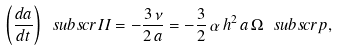<formula> <loc_0><loc_0><loc_500><loc_500>\left ( \frac { d a } { d t } \right ) \ s u b s c r { I I } = - \frac { 3 \, \nu } { 2 \, a } = - \frac { 3 } { 2 } \, \alpha \, h ^ { 2 } \, a \, \Omega \ s u b s c r { p } ,</formula> 